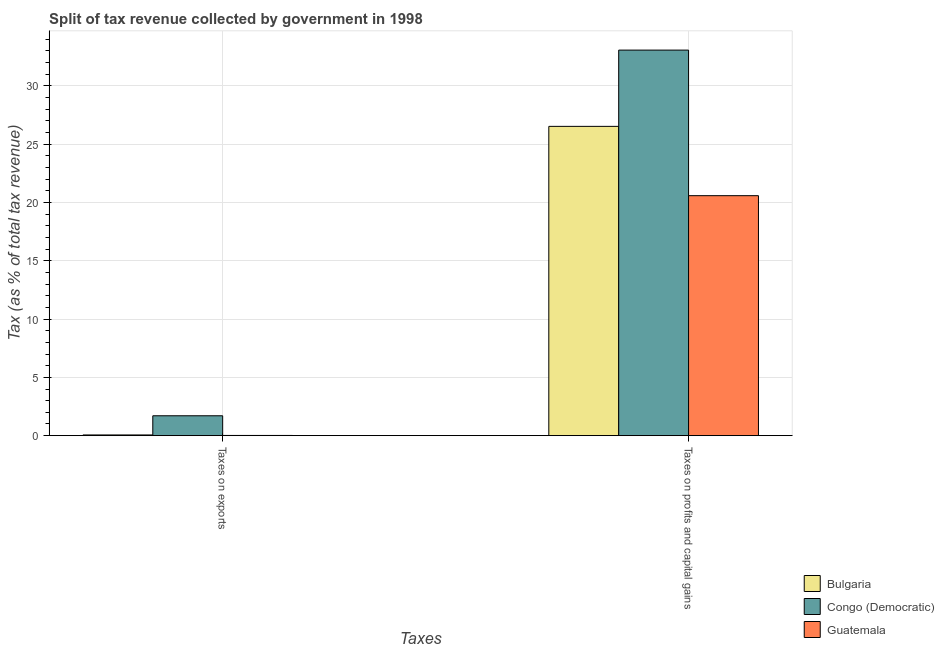How many different coloured bars are there?
Provide a succinct answer. 3. How many groups of bars are there?
Offer a terse response. 2. How many bars are there on the 1st tick from the left?
Your answer should be very brief. 3. What is the label of the 2nd group of bars from the left?
Give a very brief answer. Taxes on profits and capital gains. What is the percentage of revenue obtained from taxes on exports in Bulgaria?
Give a very brief answer. 0.06. Across all countries, what is the maximum percentage of revenue obtained from taxes on profits and capital gains?
Offer a terse response. 33.07. Across all countries, what is the minimum percentage of revenue obtained from taxes on exports?
Keep it short and to the point. 0.02. In which country was the percentage of revenue obtained from taxes on profits and capital gains maximum?
Ensure brevity in your answer.  Congo (Democratic). In which country was the percentage of revenue obtained from taxes on exports minimum?
Give a very brief answer. Guatemala. What is the total percentage of revenue obtained from taxes on profits and capital gains in the graph?
Your answer should be very brief. 80.17. What is the difference between the percentage of revenue obtained from taxes on profits and capital gains in Guatemala and that in Bulgaria?
Your answer should be compact. -5.94. What is the difference between the percentage of revenue obtained from taxes on exports in Bulgaria and the percentage of revenue obtained from taxes on profits and capital gains in Guatemala?
Give a very brief answer. -20.52. What is the average percentage of revenue obtained from taxes on exports per country?
Ensure brevity in your answer.  0.59. What is the difference between the percentage of revenue obtained from taxes on profits and capital gains and percentage of revenue obtained from taxes on exports in Bulgaria?
Provide a succinct answer. 26.47. In how many countries, is the percentage of revenue obtained from taxes on profits and capital gains greater than 23 %?
Your answer should be compact. 2. What is the ratio of the percentage of revenue obtained from taxes on exports in Guatemala to that in Congo (Democratic)?
Give a very brief answer. 0.01. Is the percentage of revenue obtained from taxes on exports in Guatemala less than that in Bulgaria?
Ensure brevity in your answer.  Yes. In how many countries, is the percentage of revenue obtained from taxes on profits and capital gains greater than the average percentage of revenue obtained from taxes on profits and capital gains taken over all countries?
Your answer should be compact. 1. How many bars are there?
Provide a succinct answer. 6. Does the graph contain any zero values?
Provide a succinct answer. No. Does the graph contain grids?
Offer a very short reply. Yes. Where does the legend appear in the graph?
Keep it short and to the point. Bottom right. What is the title of the graph?
Keep it short and to the point. Split of tax revenue collected by government in 1998. What is the label or title of the X-axis?
Give a very brief answer. Taxes. What is the label or title of the Y-axis?
Your answer should be very brief. Tax (as % of total tax revenue). What is the Tax (as % of total tax revenue) of Bulgaria in Taxes on exports?
Offer a terse response. 0.06. What is the Tax (as % of total tax revenue) in Congo (Democratic) in Taxes on exports?
Offer a very short reply. 1.7. What is the Tax (as % of total tax revenue) of Guatemala in Taxes on exports?
Your response must be concise. 0.02. What is the Tax (as % of total tax revenue) in Bulgaria in Taxes on profits and capital gains?
Give a very brief answer. 26.53. What is the Tax (as % of total tax revenue) of Congo (Democratic) in Taxes on profits and capital gains?
Provide a succinct answer. 33.07. What is the Tax (as % of total tax revenue) of Guatemala in Taxes on profits and capital gains?
Your answer should be compact. 20.58. Across all Taxes, what is the maximum Tax (as % of total tax revenue) of Bulgaria?
Your response must be concise. 26.53. Across all Taxes, what is the maximum Tax (as % of total tax revenue) in Congo (Democratic)?
Your answer should be compact. 33.07. Across all Taxes, what is the maximum Tax (as % of total tax revenue) of Guatemala?
Offer a terse response. 20.58. Across all Taxes, what is the minimum Tax (as % of total tax revenue) in Bulgaria?
Offer a very short reply. 0.06. Across all Taxes, what is the minimum Tax (as % of total tax revenue) of Congo (Democratic)?
Provide a succinct answer. 1.7. Across all Taxes, what is the minimum Tax (as % of total tax revenue) in Guatemala?
Your answer should be very brief. 0.02. What is the total Tax (as % of total tax revenue) of Bulgaria in the graph?
Make the answer very short. 26.59. What is the total Tax (as % of total tax revenue) in Congo (Democratic) in the graph?
Keep it short and to the point. 34.77. What is the total Tax (as % of total tax revenue) of Guatemala in the graph?
Offer a very short reply. 20.6. What is the difference between the Tax (as % of total tax revenue) in Bulgaria in Taxes on exports and that in Taxes on profits and capital gains?
Your response must be concise. -26.47. What is the difference between the Tax (as % of total tax revenue) in Congo (Democratic) in Taxes on exports and that in Taxes on profits and capital gains?
Your answer should be compact. -31.36. What is the difference between the Tax (as % of total tax revenue) in Guatemala in Taxes on exports and that in Taxes on profits and capital gains?
Offer a terse response. -20.56. What is the difference between the Tax (as % of total tax revenue) of Bulgaria in Taxes on exports and the Tax (as % of total tax revenue) of Congo (Democratic) in Taxes on profits and capital gains?
Make the answer very short. -33.01. What is the difference between the Tax (as % of total tax revenue) in Bulgaria in Taxes on exports and the Tax (as % of total tax revenue) in Guatemala in Taxes on profits and capital gains?
Provide a short and direct response. -20.52. What is the difference between the Tax (as % of total tax revenue) of Congo (Democratic) in Taxes on exports and the Tax (as % of total tax revenue) of Guatemala in Taxes on profits and capital gains?
Your response must be concise. -18.88. What is the average Tax (as % of total tax revenue) of Bulgaria per Taxes?
Give a very brief answer. 13.29. What is the average Tax (as % of total tax revenue) of Congo (Democratic) per Taxes?
Provide a succinct answer. 17.39. What is the average Tax (as % of total tax revenue) of Guatemala per Taxes?
Your answer should be compact. 10.3. What is the difference between the Tax (as % of total tax revenue) in Bulgaria and Tax (as % of total tax revenue) in Congo (Democratic) in Taxes on exports?
Your answer should be compact. -1.64. What is the difference between the Tax (as % of total tax revenue) in Bulgaria and Tax (as % of total tax revenue) in Guatemala in Taxes on exports?
Keep it short and to the point. 0.04. What is the difference between the Tax (as % of total tax revenue) of Congo (Democratic) and Tax (as % of total tax revenue) of Guatemala in Taxes on exports?
Your response must be concise. 1.69. What is the difference between the Tax (as % of total tax revenue) in Bulgaria and Tax (as % of total tax revenue) in Congo (Democratic) in Taxes on profits and capital gains?
Your response must be concise. -6.54. What is the difference between the Tax (as % of total tax revenue) of Bulgaria and Tax (as % of total tax revenue) of Guatemala in Taxes on profits and capital gains?
Your answer should be compact. 5.94. What is the difference between the Tax (as % of total tax revenue) of Congo (Democratic) and Tax (as % of total tax revenue) of Guatemala in Taxes on profits and capital gains?
Your response must be concise. 12.49. What is the ratio of the Tax (as % of total tax revenue) in Bulgaria in Taxes on exports to that in Taxes on profits and capital gains?
Give a very brief answer. 0. What is the ratio of the Tax (as % of total tax revenue) in Congo (Democratic) in Taxes on exports to that in Taxes on profits and capital gains?
Provide a succinct answer. 0.05. What is the ratio of the Tax (as % of total tax revenue) in Guatemala in Taxes on exports to that in Taxes on profits and capital gains?
Your answer should be very brief. 0. What is the difference between the highest and the second highest Tax (as % of total tax revenue) of Bulgaria?
Make the answer very short. 26.47. What is the difference between the highest and the second highest Tax (as % of total tax revenue) of Congo (Democratic)?
Your answer should be very brief. 31.36. What is the difference between the highest and the second highest Tax (as % of total tax revenue) of Guatemala?
Offer a terse response. 20.56. What is the difference between the highest and the lowest Tax (as % of total tax revenue) of Bulgaria?
Provide a succinct answer. 26.47. What is the difference between the highest and the lowest Tax (as % of total tax revenue) in Congo (Democratic)?
Your answer should be very brief. 31.36. What is the difference between the highest and the lowest Tax (as % of total tax revenue) in Guatemala?
Ensure brevity in your answer.  20.56. 